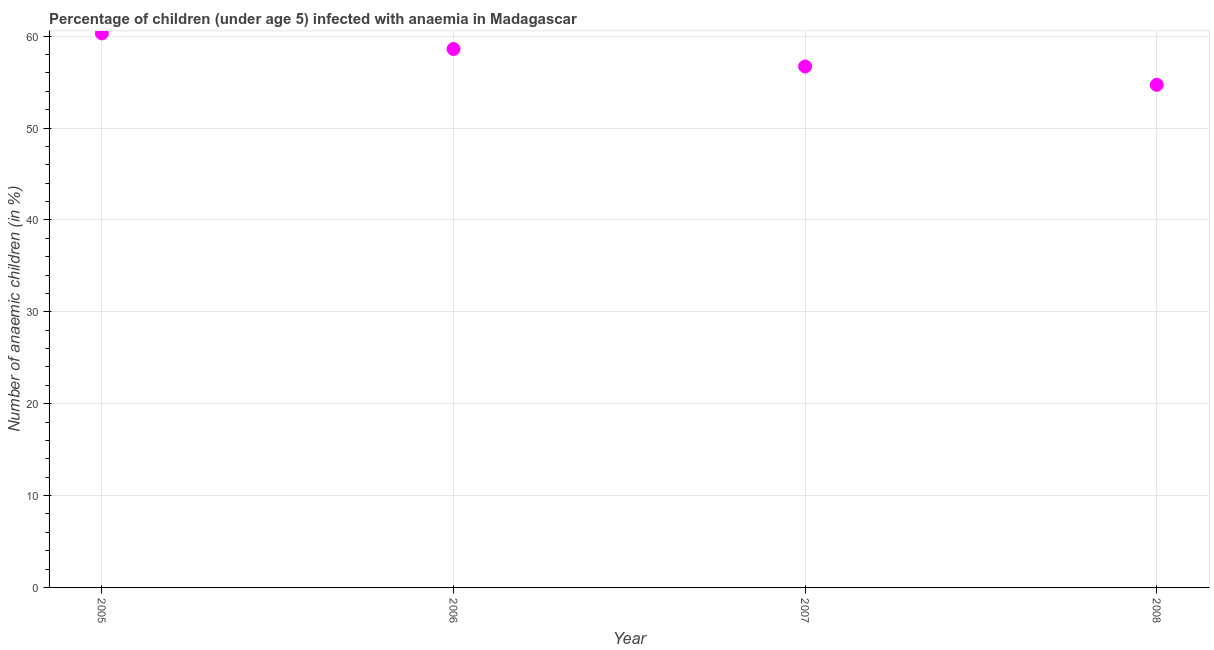What is the number of anaemic children in 2008?
Your answer should be compact. 54.7. Across all years, what is the maximum number of anaemic children?
Make the answer very short. 60.3. Across all years, what is the minimum number of anaemic children?
Offer a terse response. 54.7. In which year was the number of anaemic children minimum?
Keep it short and to the point. 2008. What is the sum of the number of anaemic children?
Your response must be concise. 230.3. What is the difference between the number of anaemic children in 2007 and 2008?
Your answer should be compact. 2. What is the average number of anaemic children per year?
Ensure brevity in your answer.  57.58. What is the median number of anaemic children?
Keep it short and to the point. 57.65. Do a majority of the years between 2005 and 2007 (inclusive) have number of anaemic children greater than 24 %?
Offer a terse response. Yes. What is the ratio of the number of anaemic children in 2006 to that in 2008?
Keep it short and to the point. 1.07. Is the number of anaemic children in 2005 less than that in 2007?
Provide a short and direct response. No. What is the difference between the highest and the second highest number of anaemic children?
Offer a terse response. 1.7. Is the sum of the number of anaemic children in 2005 and 2007 greater than the maximum number of anaemic children across all years?
Provide a short and direct response. Yes. What is the difference between the highest and the lowest number of anaemic children?
Your response must be concise. 5.6. How many dotlines are there?
Your answer should be very brief. 1. What is the title of the graph?
Give a very brief answer. Percentage of children (under age 5) infected with anaemia in Madagascar. What is the label or title of the Y-axis?
Your answer should be compact. Number of anaemic children (in %). What is the Number of anaemic children (in %) in 2005?
Offer a terse response. 60.3. What is the Number of anaemic children (in %) in 2006?
Keep it short and to the point. 58.6. What is the Number of anaemic children (in %) in 2007?
Provide a short and direct response. 56.7. What is the Number of anaemic children (in %) in 2008?
Give a very brief answer. 54.7. What is the difference between the Number of anaemic children (in %) in 2005 and 2006?
Make the answer very short. 1.7. What is the difference between the Number of anaemic children (in %) in 2005 and 2007?
Provide a succinct answer. 3.6. What is the difference between the Number of anaemic children (in %) in 2006 and 2007?
Make the answer very short. 1.9. What is the difference between the Number of anaemic children (in %) in 2007 and 2008?
Provide a short and direct response. 2. What is the ratio of the Number of anaemic children (in %) in 2005 to that in 2007?
Offer a terse response. 1.06. What is the ratio of the Number of anaemic children (in %) in 2005 to that in 2008?
Make the answer very short. 1.1. What is the ratio of the Number of anaemic children (in %) in 2006 to that in 2007?
Make the answer very short. 1.03. What is the ratio of the Number of anaemic children (in %) in 2006 to that in 2008?
Ensure brevity in your answer.  1.07. 